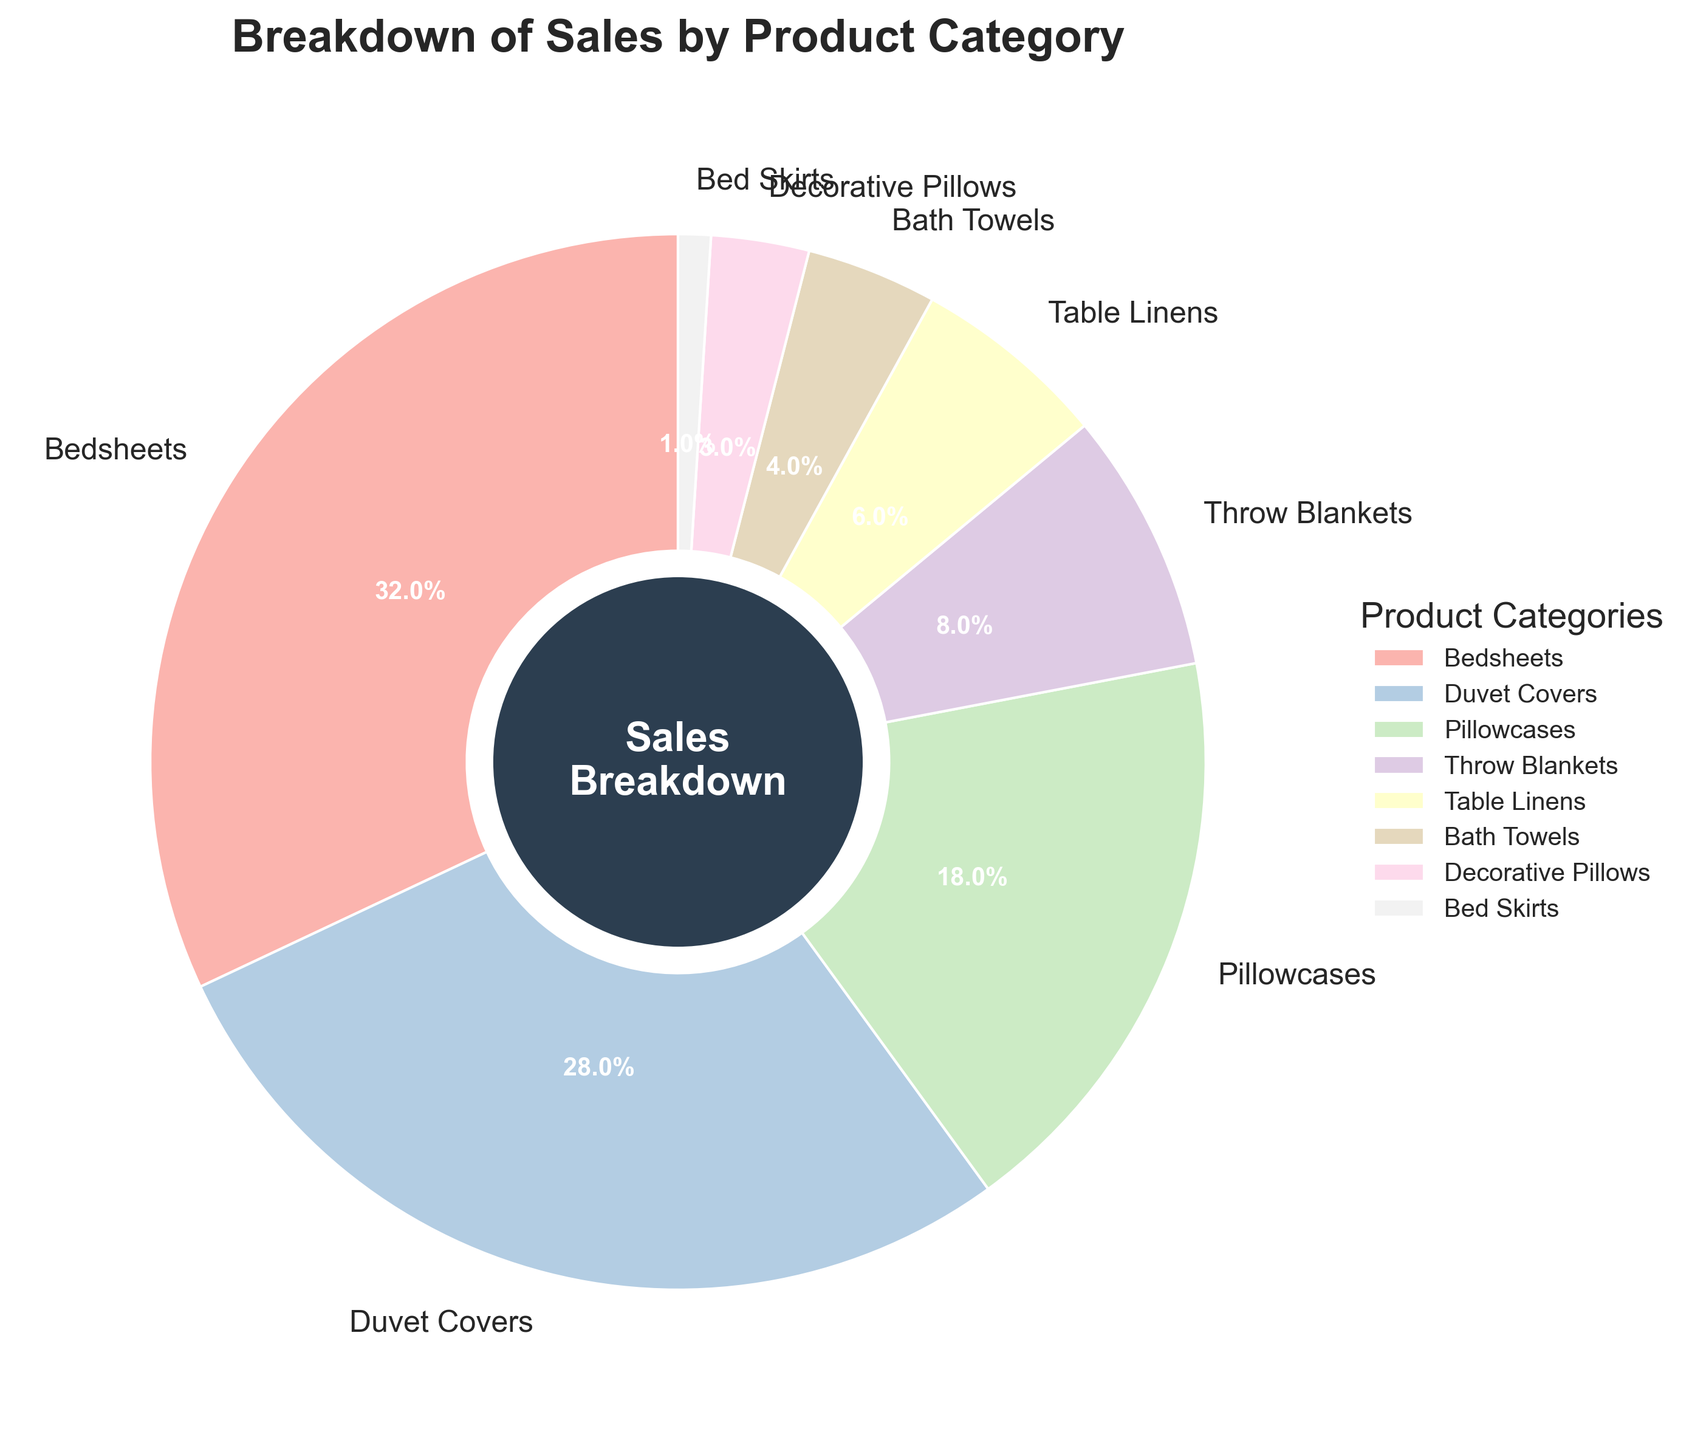What percentage of total sales do Bedsheets and Duvet Covers together account for? To find the combined sales percentage for Bedsheets and Duvet Covers, add their individual sales percentages. Bedsheets have 32% and Duvet Covers have 28%, so their combined sales percentage is 32% + 28% = 60%
Answer: 60% Which product category accounts for the smallest percentage of sales? Look at the chart to identify the product category with the smallest segment. The smallest segment in the chart represents Bed Skirts, which accounts for 1% of total sales
Answer: Bed Skirts How does the sales percentage of Pillowcases compare with that of Throw Blankets? Compare the sales percentages given for Pillowcases and Throw Blankets. Pillowcases have 18% and Throw Blankets have 8%. Since 18% is greater than 8%, Pillowcases have a higher sales percentage than Throw Blankets
Answer: Pillowcases have a higher sales percentage Which three product categories have the highest sales percentages, and what is their combined percentage? Examine the chart to identify the top three product categories by their sales percentages. Bedsheets (32%), Duvet Covers (28%), and Pillowcases (18%) are the top three. Their combined percentage is 32% + 28% + 18% = 78%
Answer: Bedsheets, Duvet Covers, and Pillowcases with a combined 78% What is the difference in sales percentage between Decorative Pillows and Bath Towels? Compare the sales percentages for Decorative Pillows (3%) and Bath Towels (4%). The difference is calculated as 4% - 3% = 1%
Answer: 1% If you combine the sales percentages of Table Linens and Decorative Pillows, will it exceed 10%? Add the sales percentages for Table Linens (6%) and Decorative Pillows (3%). The combined total is 6% + 3% = 9%, which does not exceed 10%
Answer: No, they sum to 9% Is the sales percentage of Table Linens greater than half the sales percentage of Bedsheets? First, calculate half of Bedsheets' sales percentage, which is 32% / 2 = 16%. Compare this with Table Linens' sales percentage (6%). Since 6% is less than 16%, Table Linens' sales percentage is not greater than half of Bedsheets' sales
Answer: No By what percentage does the sales percentage of Throw Blankets exceed that of Bed Skirts? Subtract the sales percentage of Bed Skirts (1%) from that of Throw Blankets (8%). The difference is 8% - 1% = 7%
Answer: 7% Given that Duvet Covers and Pillowcases are the second and third highest-selling product categories respectively, what is the sales percentage difference between them and Bedsheets? Bedsheets have the highest sales percentage at 32%. Duvet Covers (second) have 28%, and Pillowcases (third) have 18%. The differences are 32% - 28% = 4% and 32% - 18% = 14%
Answer: 4% between Bedsheets and Duvet Covers, 14% between Bedsheets and Pillowcases 